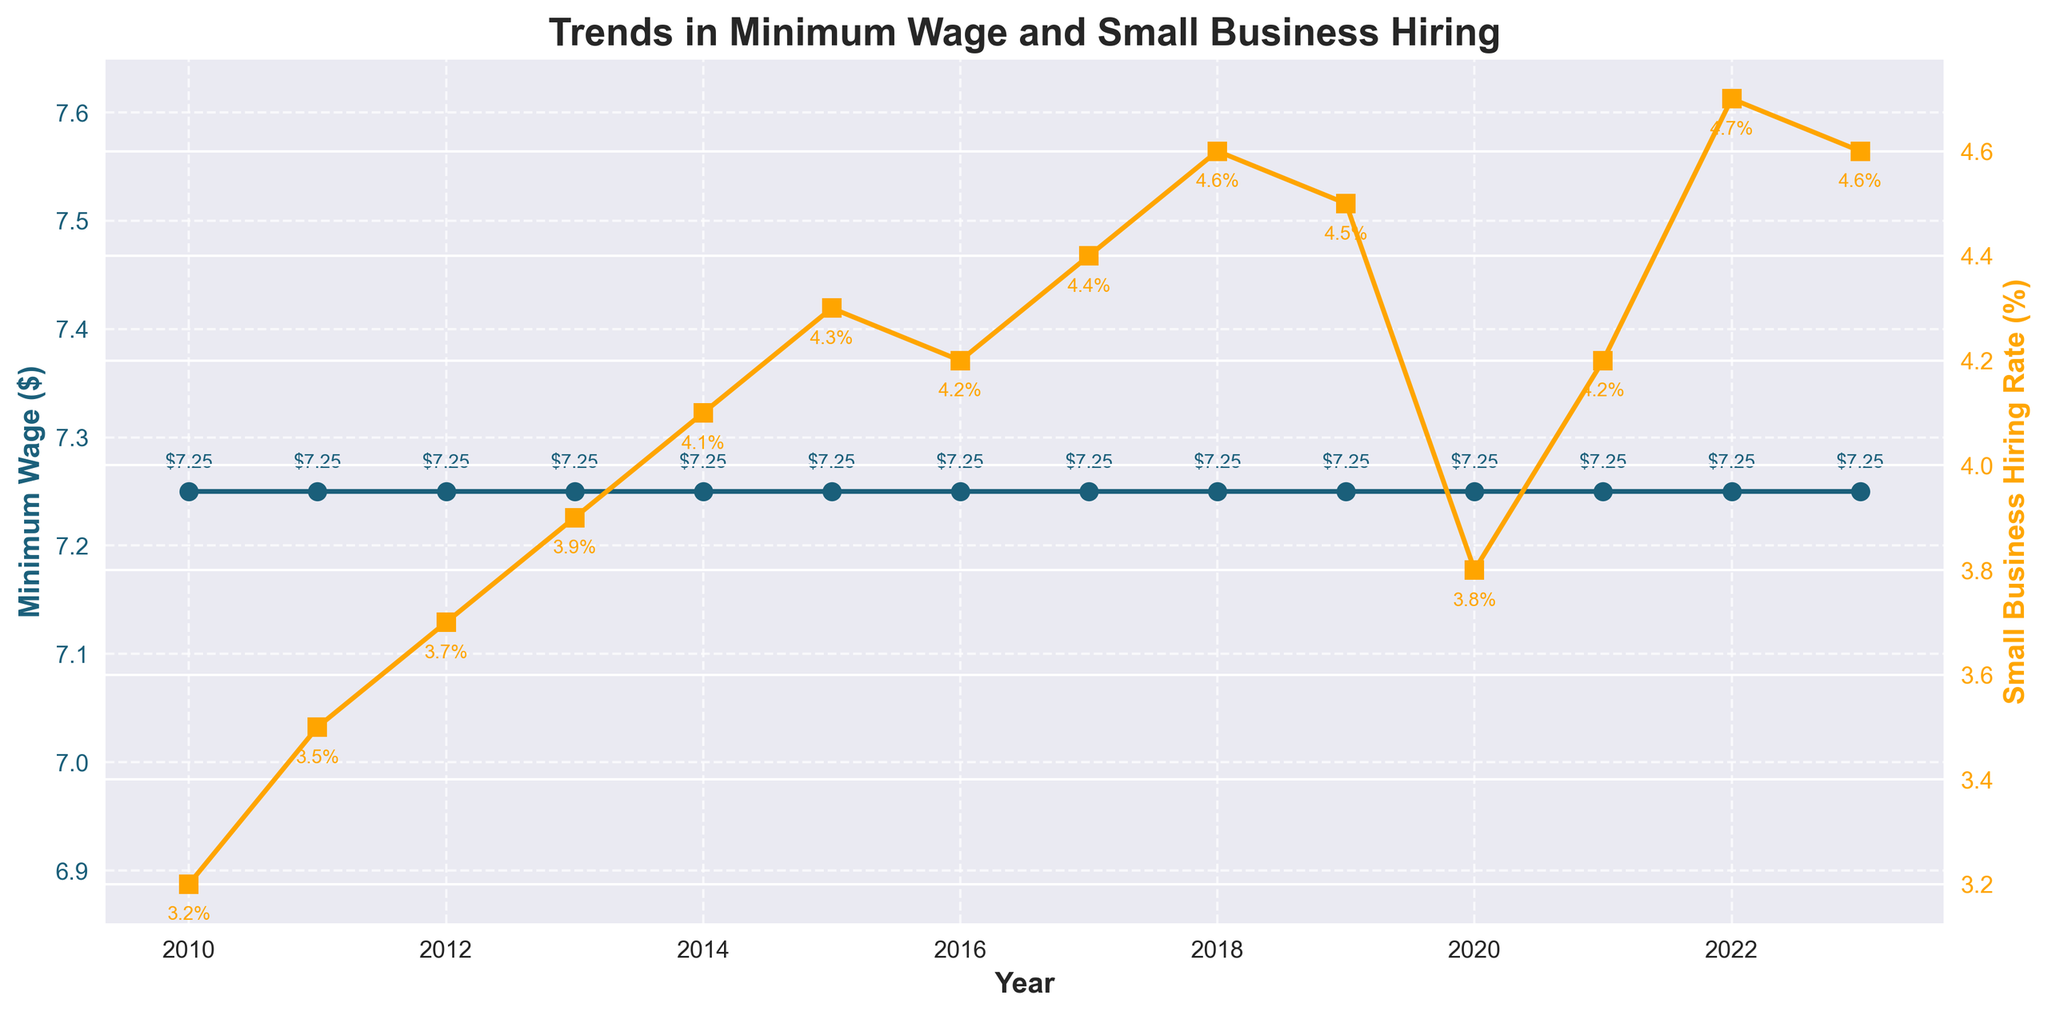What has been the trend in the minimum wage from 2010 to 2023? The minimum wage has remained constant at $7.25 from 2010 to 2023. This can be observed as the line representing the minimum wage is flat throughout the time period.
Answer: $7.25 How did the Small Business Hiring Rate change from 2010 to 2023? The Small Business Hiring Rate generally increased from 3.2% in 2010 to 4.6% in 2023, with a dip to 3.8% in 2020. This can be observed from the upward trend in the line representing the hiring rate, with a notable drop in 2020.
Answer: Increased Which year had the highest Small Business Hiring Rate, and what was the rate? The highest Small Business Hiring Rate was in 2022, where it reached 4.7%. This can be observed as the peak value of the orange line.
Answer: 2022, 4.7% By how much did the Small Business Hiring Rate change from 2010 to 2015? The Small Business Hiring Rate increased from 3.2% in 2010 to 4.3% in 2015. The change can be calculated as 4.3% - 3.2%, which is 1.1%.
Answer: 1.1% In which year did the Small Business Hiring Rate experience the most significant increase from the previous year? From 2014 to 2015, the Small Business Hiring Rate increased from 4.1% to 4.3%, which is a significant increase of 0.2%. This can be observed as the steepest upward segment in the orange line.
Answer: 2014-2015 Compare the Small Business Hiring Rate between 2019 and 2020. What is the difference? The Small Business Hiring Rate was 4.5% in 2019 and 3.8% in 2020. The difference can be calculated as 4.5% - 3.8% = 0.7%.
Answer: 0.7% What can you infer about the relationship between the minimum wage and the Small Business Hiring Rate over the years? The minimum wage remained constant at $7.25, while the Small Business Hiring Rate generally increased, suggesting that factors other than minimum wage might have influenced hiring rates.
Answer: Minimum wage constant, hiring rate increased What was the average Small Business Hiring Rate from 2010 to 2023? The average Small Business Hiring Rate over the years can be calculated by summing the hiring rates and dividing by the number of years (14), i.e., (3.2 + 3.5 + 3.7 + 3.9 + 4.1 + 4.3 + 4.2 + 4.4 + 4.6 + 4.5 + 3.8 + 4.2 + 4.7 + 4.6) / 14 = 4.136%.
Answer: 4.14% Compare the Small Business Hiring Rate in 2010 and 2023. How much did it increase in percentage terms? The hiring rate increased from 3.2% in 2010 to 4.6% in 2023. The increase in percentage terms is ((4.6 - 3.2) / 3.2) * 100 = 43.75%.
Answer: 43.75% Which year(s) experienced a decrease in the Small Business Hiring Rate compared to the previous year? The years 2016, 2019, and 2023 experienced decreases in the Small Business Hiring Rate compared to their previous years. This can be observed as downward segments in the orange line for those years.
Answer: 2016, 2019, 2023 